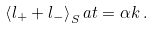Convert formula to latex. <formula><loc_0><loc_0><loc_500><loc_500>\left < l _ { + } + l _ { - } \right > _ { S } a t = \alpha k \, .</formula> 